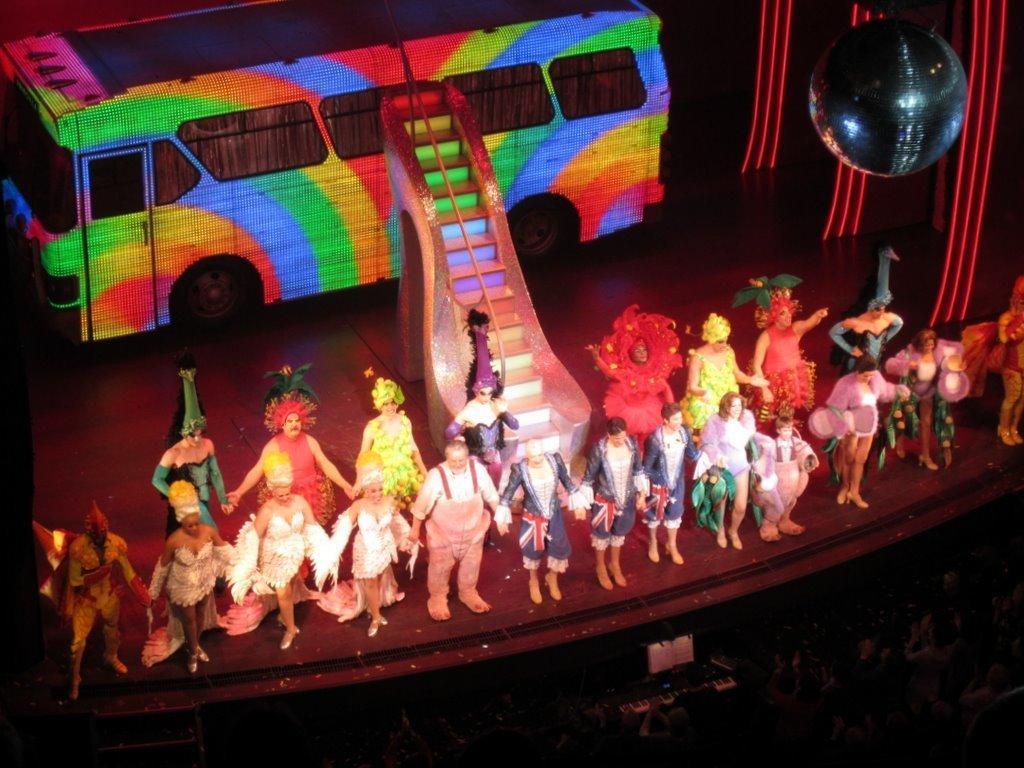In one or two sentences, can you explain what this image depicts? In this image we can see few persons are standing by holding each other hands on the stage and we can see a bus, steps and a spherical object. At the bottom we can see audience. 